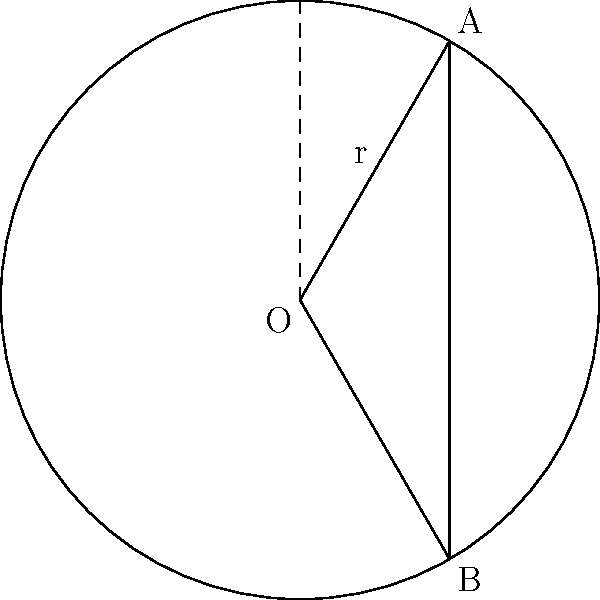As a first-time manager overseeing a project involving circular structures, you need to calculate the area of a specific segment. In the circle above with center O and radius $r$, chord AB forms a central angle of 120°. What is the area of the shaded segment, expressed in terms of $r^2$? Let's approach this step-by-step:

1) The area of a circular segment is given by the formula:
   Area = Area of sector - Area of triangle

2) For a central angle $\theta$ in radians:
   Area of sector = $\frac{1}{2}r^2\theta$
   Area of triangle = $\frac{1}{2}r^2\sin\theta$

3) Given angle is 120°. Convert to radians:
   $\theta = 120° \times \frac{\pi}{180°} = \frac{2\pi}{3}$

4) Calculate area of sector:
   Area of sector = $\frac{1}{2}r^2 \cdot \frac{2\pi}{3} = \frac{\pi r^2}{3}$

5) Calculate area of triangle:
   Area of triangle = $\frac{1}{2}r^2\sin(\frac{2\pi}{3}) = \frac{\sqrt{3}}{4}r^2$

6) Calculate area of segment:
   Area of segment = $\frac{\pi r^2}{3} - \frac{\sqrt{3}}{4}r^2$
                   $= (\frac{\pi}{3} - \frac{\sqrt{3}}{4})r^2$

Therefore, the area of the shaded segment is $(\frac{\pi}{3} - \frac{\sqrt{3}}{4})r^2$.
Answer: $(\frac{\pi}{3} - \frac{\sqrt{3}}{4})r^2$ 